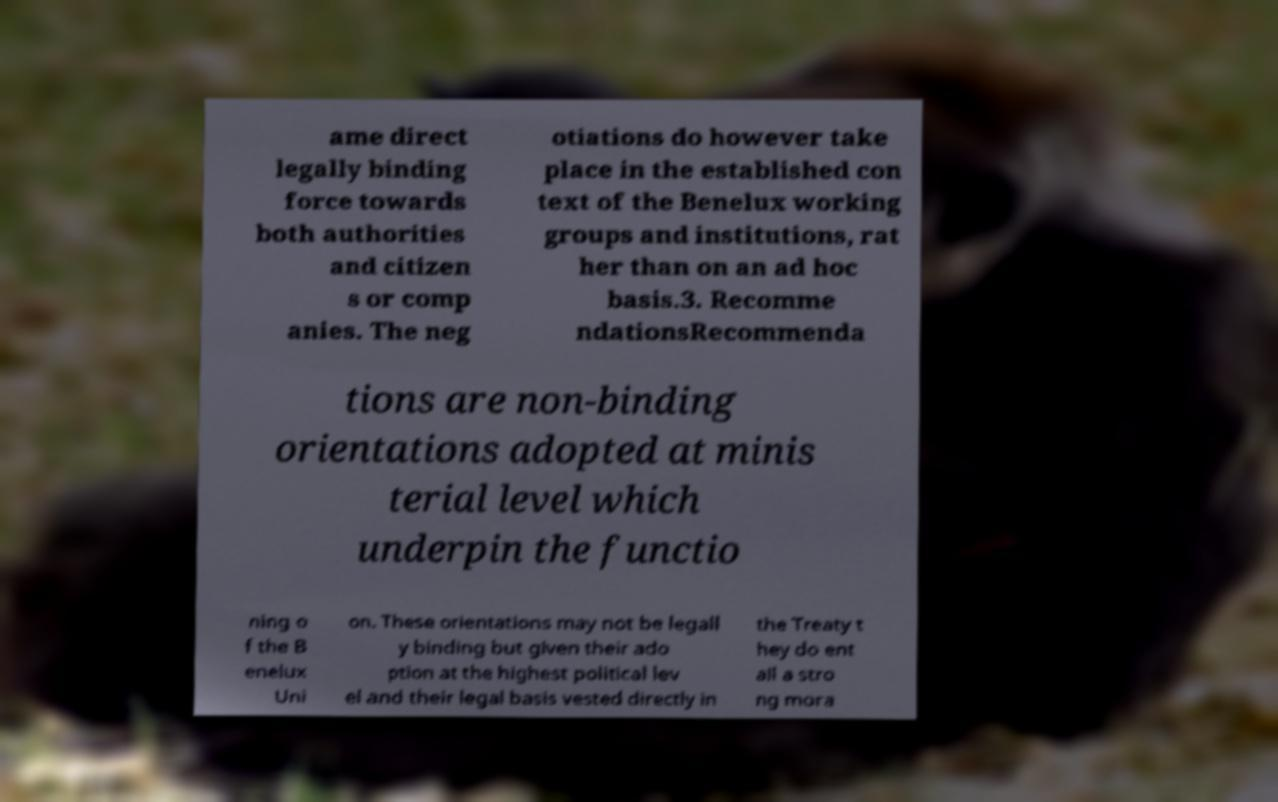For documentation purposes, I need the text within this image transcribed. Could you provide that? ame direct legally binding force towards both authorities and citizen s or comp anies. The neg otiations do however take place in the established con text of the Benelux working groups and institutions, rat her than on an ad hoc basis.3. Recomme ndationsRecommenda tions are non-binding orientations adopted at minis terial level which underpin the functio ning o f the B enelux Uni on. These orientations may not be legall y binding but given their ado ption at the highest political lev el and their legal basis vested directly in the Treaty t hey do ent ail a stro ng mora 